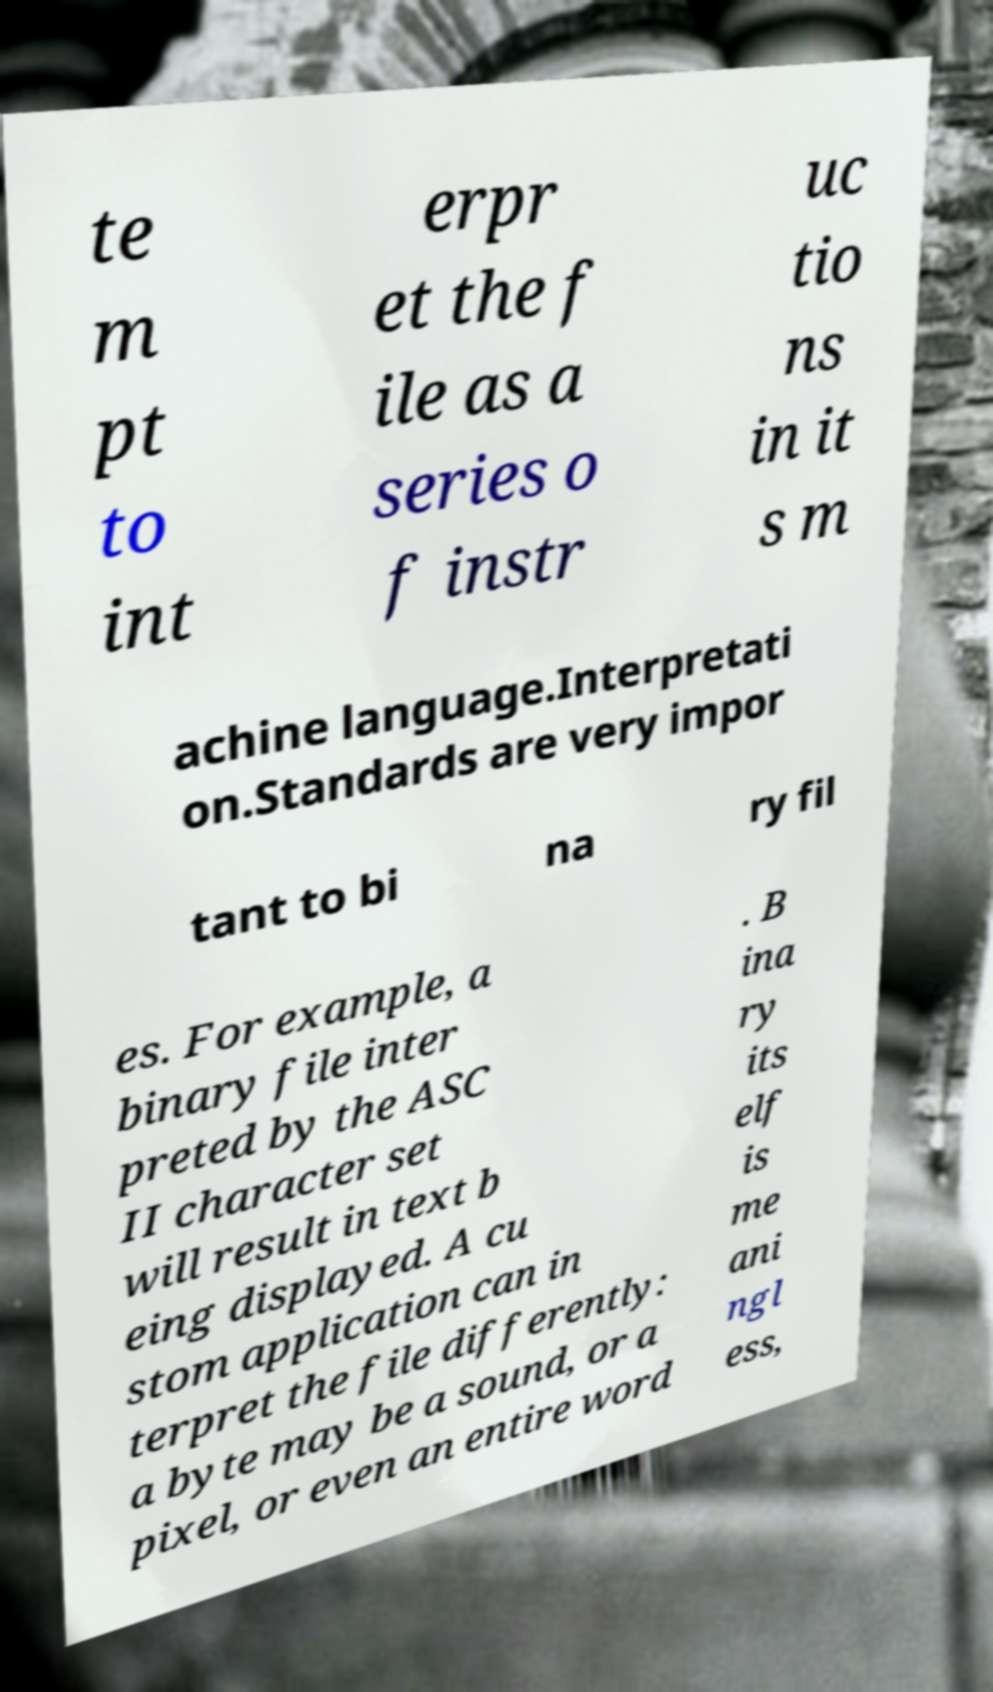Can you read and provide the text displayed in the image?This photo seems to have some interesting text. Can you extract and type it out for me? te m pt to int erpr et the f ile as a series o f instr uc tio ns in it s m achine language.Interpretati on.Standards are very impor tant to bi na ry fil es. For example, a binary file inter preted by the ASC II character set will result in text b eing displayed. A cu stom application can in terpret the file differently: a byte may be a sound, or a pixel, or even an entire word . B ina ry its elf is me ani ngl ess, 